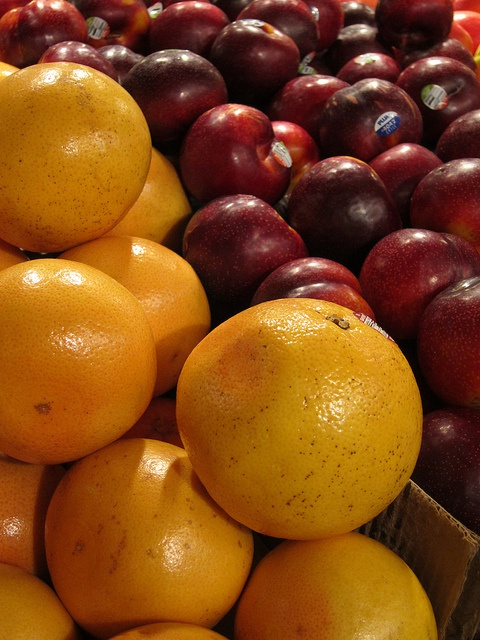Describe the objects in this image and their specific colors. I can see orange in brown, red, orange, and maroon tones, apple in brown, maroon, and black tones, apple in brown, black, and maroon tones, apple in brown, black, and maroon tones, and apple in brown, maroon, and black tones in this image. 